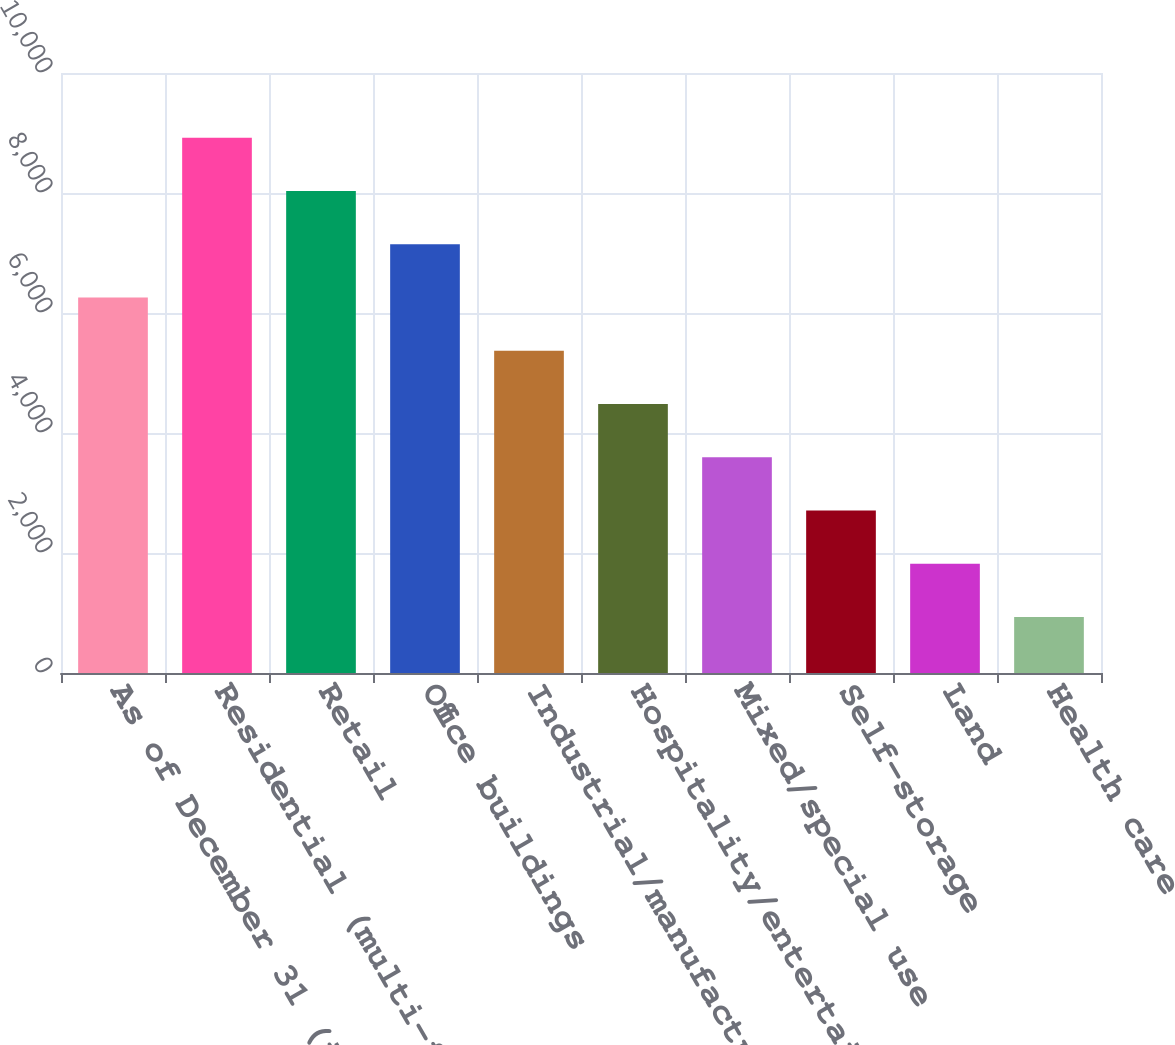Convert chart. <chart><loc_0><loc_0><loc_500><loc_500><bar_chart><fcel>As of December 31 (in<fcel>Residential (multi-family)<fcel>Retail<fcel>Office buildings<fcel>Industrial/manufacturing<fcel>Hospitality/entertainment<fcel>Mixed/special use<fcel>Self-storage<fcel>Land<fcel>Health care<nl><fcel>6258.5<fcel>8921.6<fcel>8033.9<fcel>7146.2<fcel>5370.8<fcel>4483.1<fcel>3595.4<fcel>2707.7<fcel>1820<fcel>932.3<nl></chart> 